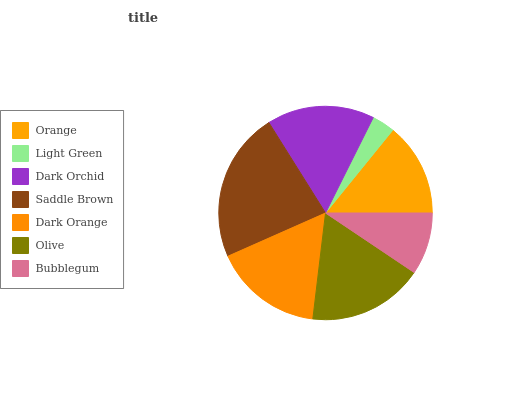Is Light Green the minimum?
Answer yes or no. Yes. Is Saddle Brown the maximum?
Answer yes or no. Yes. Is Dark Orchid the minimum?
Answer yes or no. No. Is Dark Orchid the maximum?
Answer yes or no. No. Is Dark Orchid greater than Light Green?
Answer yes or no. Yes. Is Light Green less than Dark Orchid?
Answer yes or no. Yes. Is Light Green greater than Dark Orchid?
Answer yes or no. No. Is Dark Orchid less than Light Green?
Answer yes or no. No. Is Dark Orchid the high median?
Answer yes or no. Yes. Is Dark Orchid the low median?
Answer yes or no. Yes. Is Olive the high median?
Answer yes or no. No. Is Dark Orange the low median?
Answer yes or no. No. 